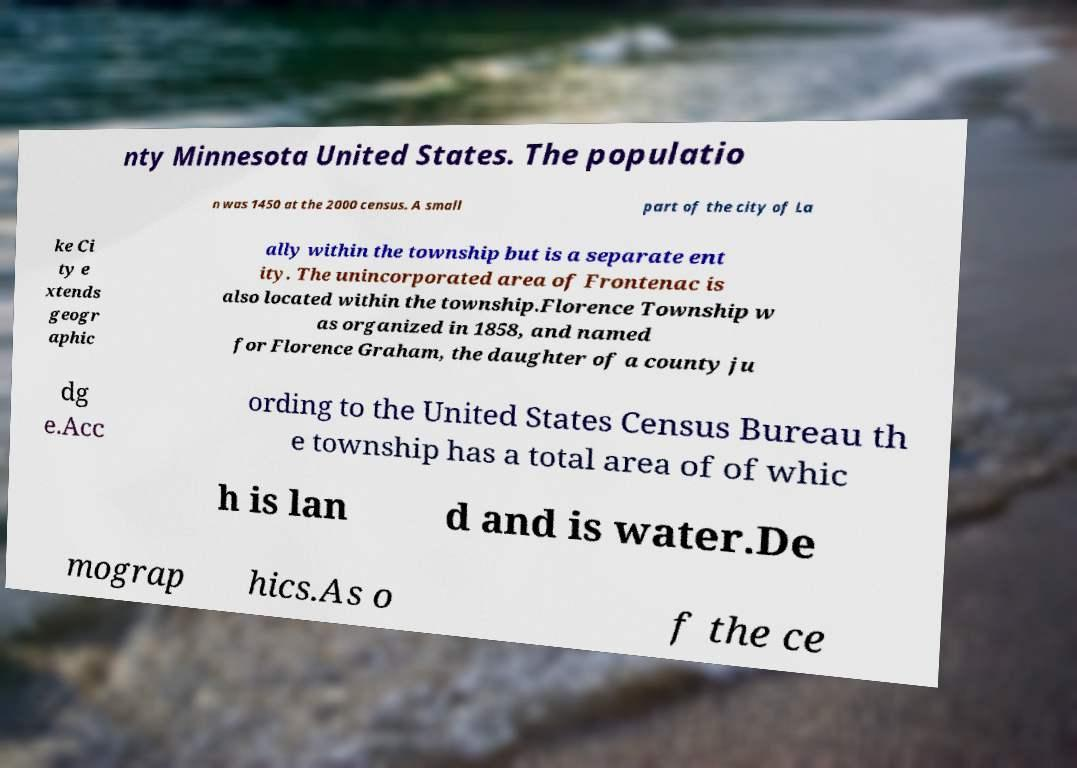Can you accurately transcribe the text from the provided image for me? nty Minnesota United States. The populatio n was 1450 at the 2000 census. A small part of the city of La ke Ci ty e xtends geogr aphic ally within the township but is a separate ent ity. The unincorporated area of Frontenac is also located within the township.Florence Township w as organized in 1858, and named for Florence Graham, the daughter of a county ju dg e.Acc ording to the United States Census Bureau th e township has a total area of of whic h is lan d and is water.De mograp hics.As o f the ce 